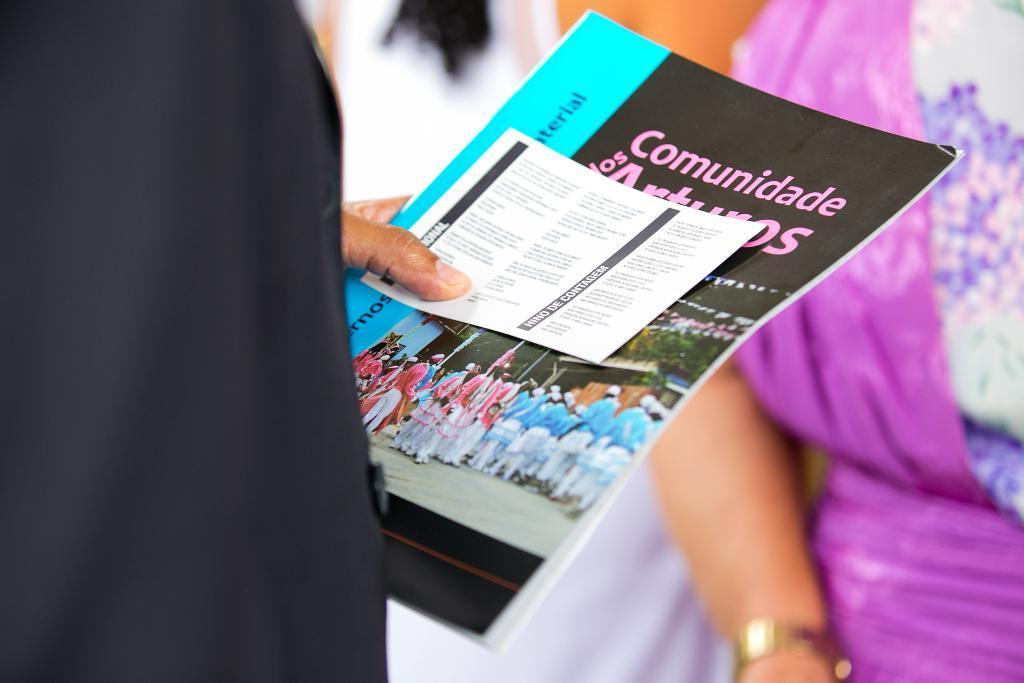Could you give a brief overview of what you see in this image? In this image in the foreground there is one person who is standing and he is holding a book and paper, in the background there are two persons. 